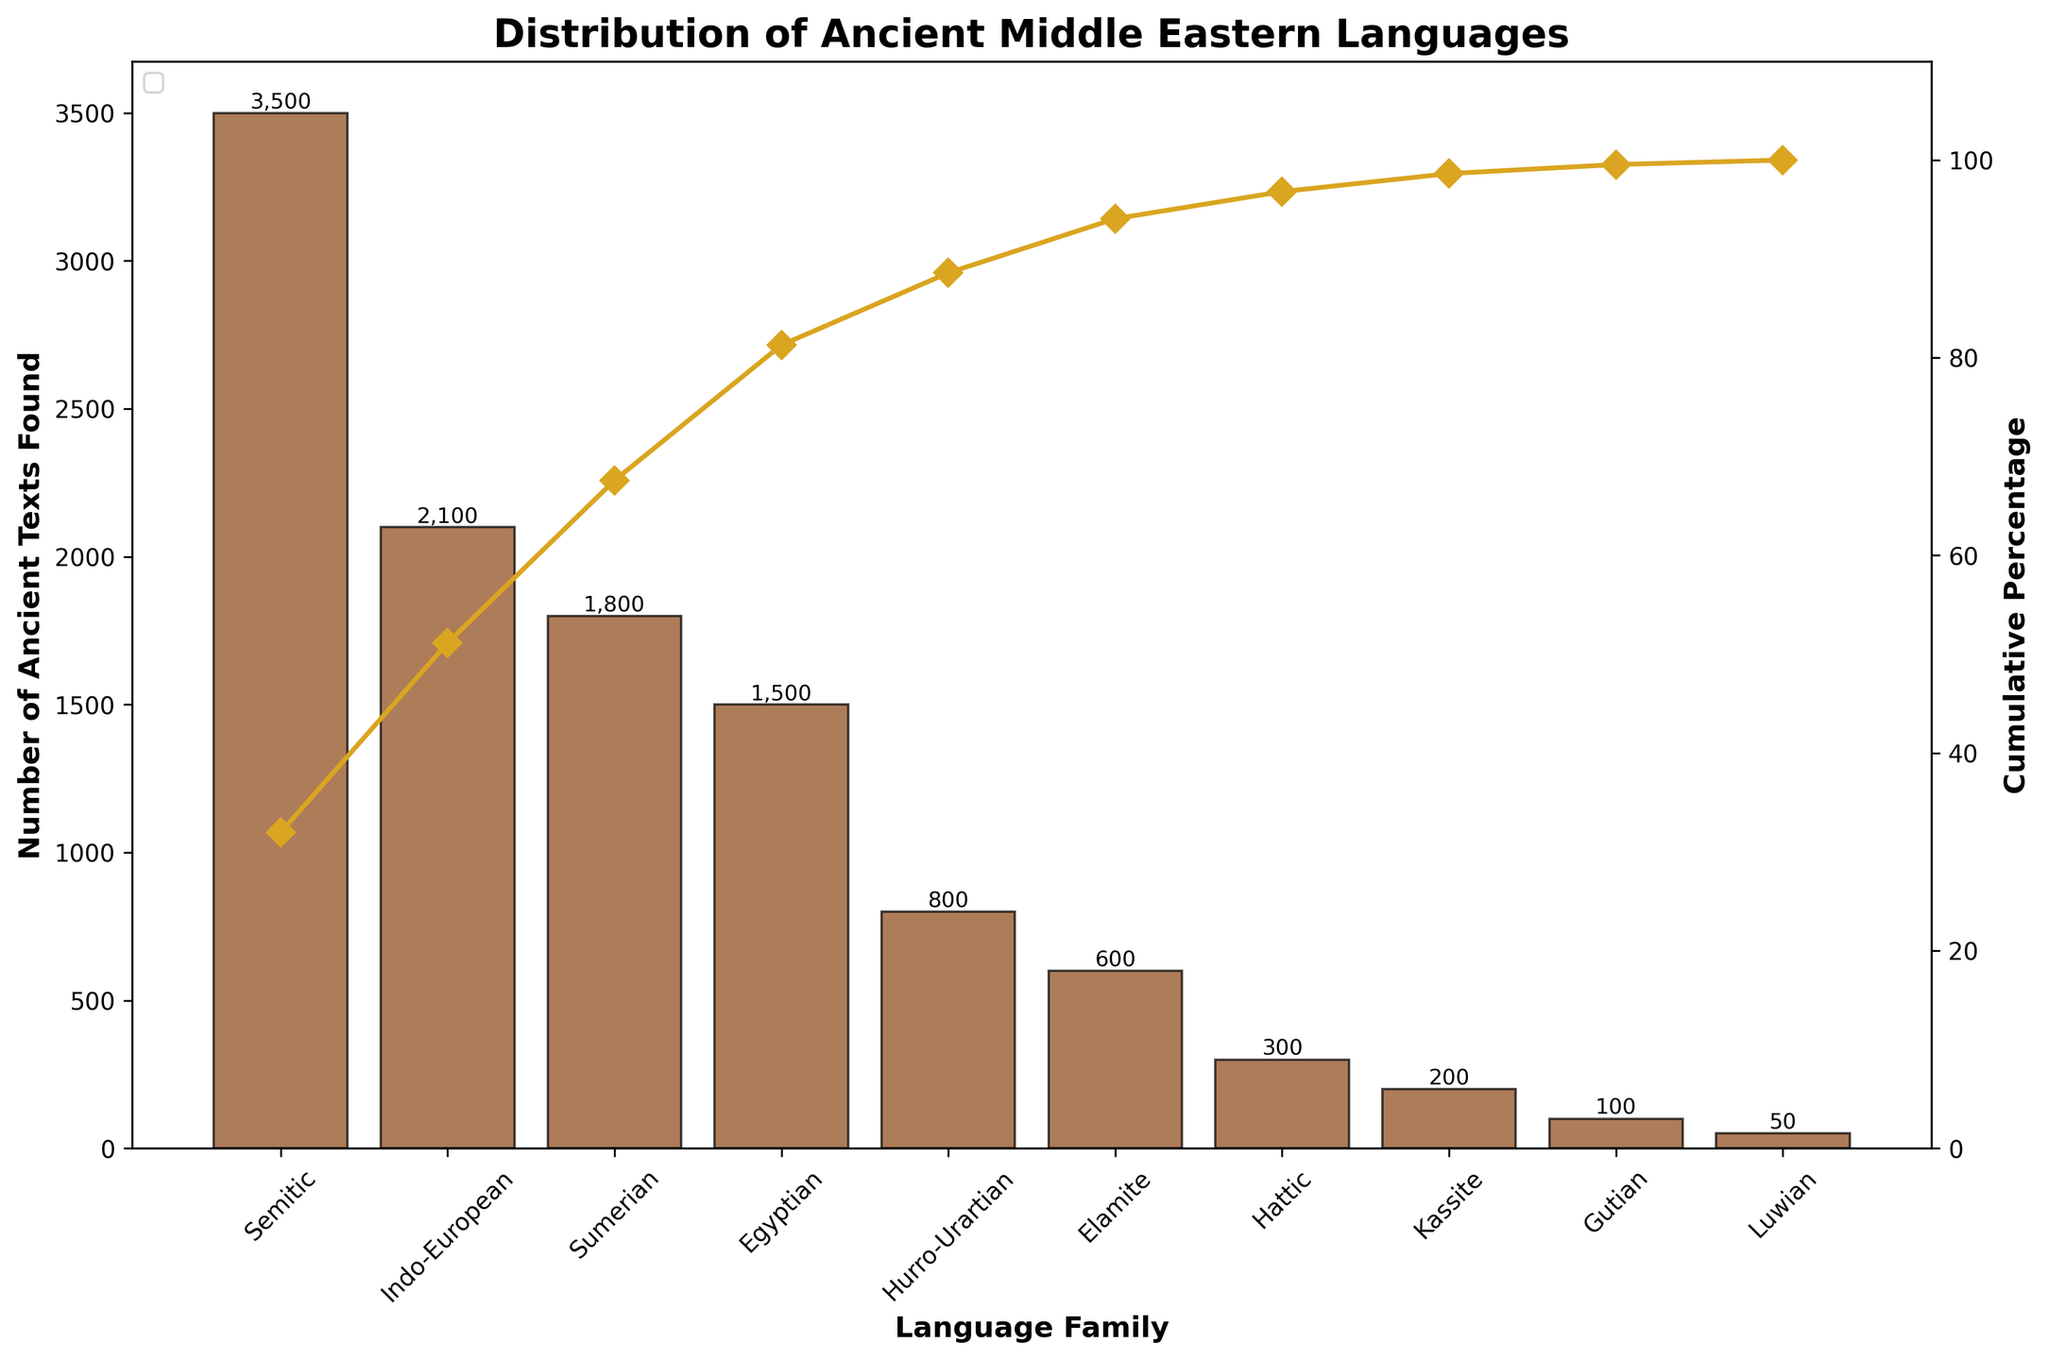What is the title of the figure? The title is prominently displayed at the top of the figure. It states what the chart is about.
Answer: Distribution of Ancient Middle Eastern Languages How many language families are represented in the figure? Count the number of bars on the bar chart, as each bar represents a different language family.
Answer: 10 Which language family has the highest number of ancient texts found? Identify the tallest bar in the bar chart, which corresponds to the language family with the highest number of texts.
Answer: Semitic What is the cumulative percentage for the Indo-European language family? Look at the line plot and find the data point corresponding to the Indo-European language family to determine its cumulative percentage.
Answer: Approximately 51.5% Which language families have more than 1,000 ancient texts found? Identify the bars that exceed the 1,000 mark on the y-axis and note their corresponding language families.
Answer: Semitic, Indo-European, Sumerian, Egyptian How many ancient texts in total are represented in the chart? Summing up the heights of all the bars gives the total number of ancient texts found across all language families.
Answer: 12,950 What percentage of the total texts do the Semitic and Indo-European language families constitute together? Add the numbers of ancient texts for both the Semitic and Indo-European families, divide by the total number of texts, and multiply by 100. [(3500 + 2100) / 12,950 * 100]
Answer: Approximately 43.2% Which language family has the lowest number of ancient texts found and what is that number? Identify the shortest bar in the bar chart and note its height and corresponding language family.
Answer: Luwian, 50 What is the difference in the number of ancient texts found between the Sumerian and Hattic language families? Subtract the number of ancient texts found in the Hattic language family from the number found in the Sumerian family. [1800 - 300]
Answer: 1,500 How does the cumulative percentage curve help in understanding the distribution of ancient texts? The cumulative percentage curve provides a visual way to see the cumulative contribution of each language family to the total number of ancient texts. The steepness of the curve indicates the concentration of texts within fewer families.
Answer: It shows the relative contribution of each family and indicates that a few families account for a large proportion of the texts 